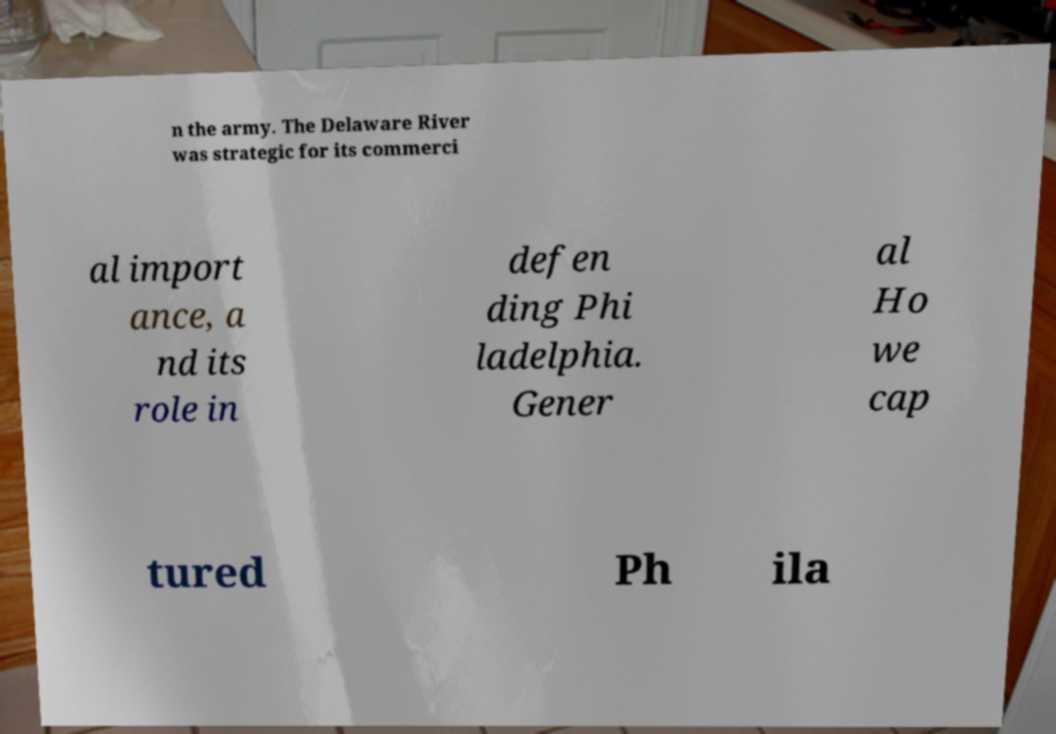Could you extract and type out the text from this image? n the army. The Delaware River was strategic for its commerci al import ance, a nd its role in defen ding Phi ladelphia. Gener al Ho we cap tured Ph ila 